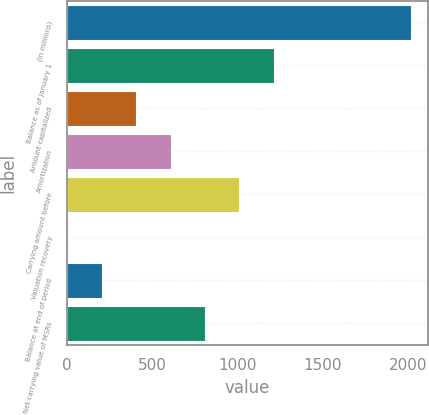Convert chart to OTSL. <chart><loc_0><loc_0><loc_500><loc_500><bar_chart><fcel>(in millions)<fcel>Balance as of January 1<fcel>Amount capitalized<fcel>Amortization<fcel>Carrying amount before<fcel>Valuation recovery<fcel>Balance at end of period<fcel>Net carrying value of MSRs<nl><fcel>2016<fcel>1211.2<fcel>406.4<fcel>607.6<fcel>1010<fcel>4<fcel>205.2<fcel>808.8<nl></chart> 